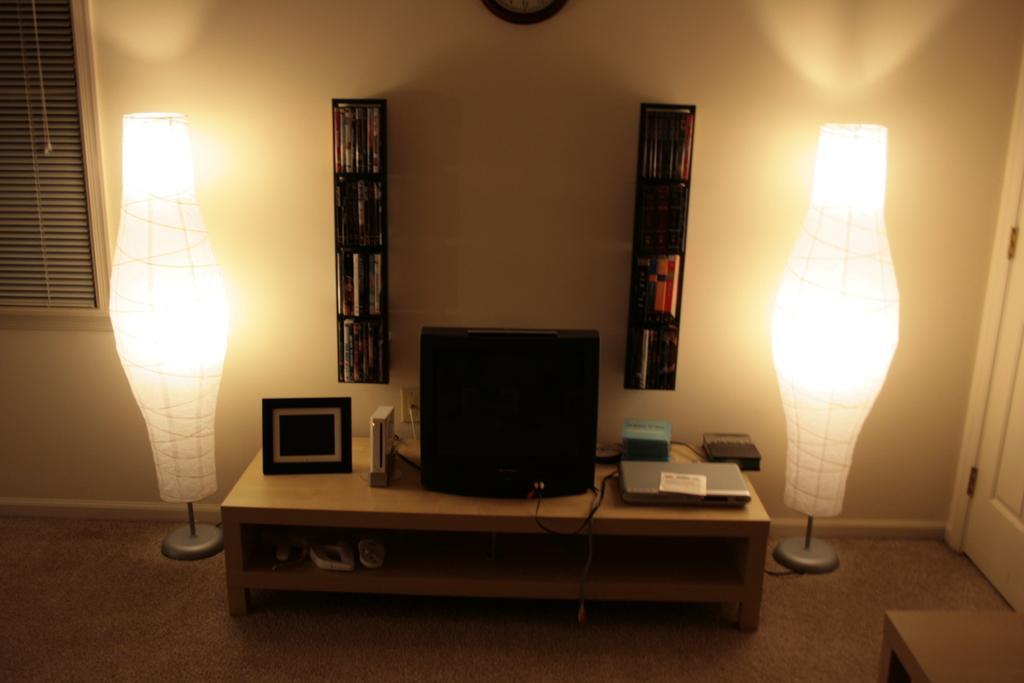Describe this image in one or two sentences. This is a table with a television,laptop,photo frame and some objects on it. These are the bookshelves attached to the wall. These are the lamps beside the table. I think this is the door. This is the window. 